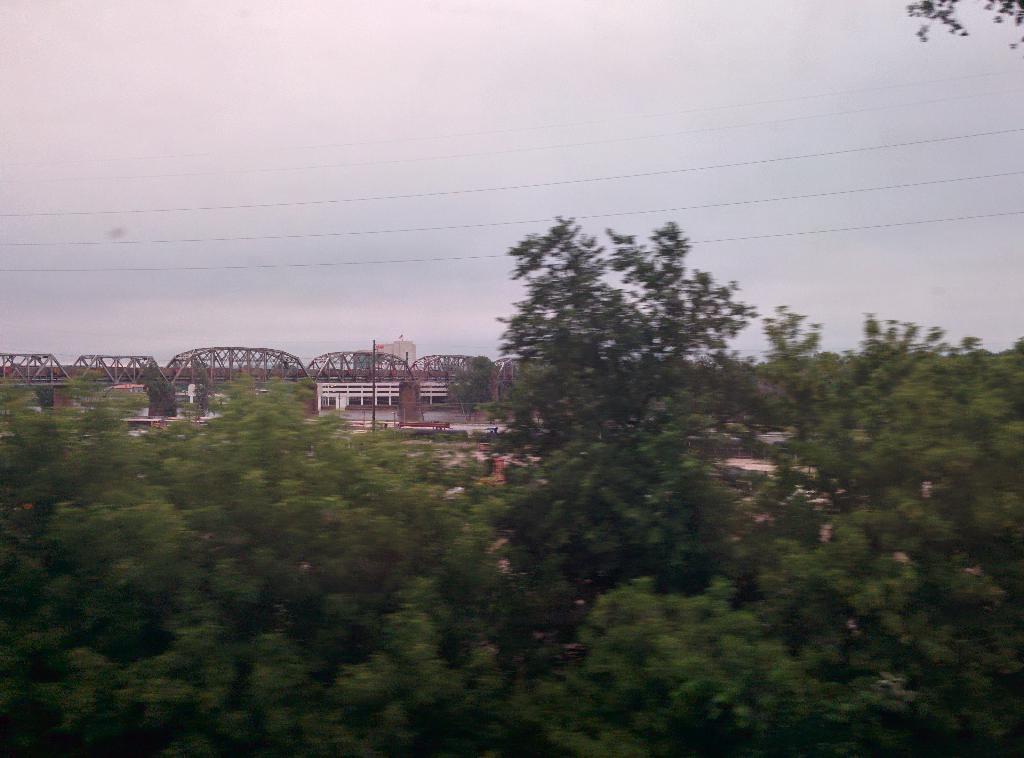In one or two sentences, can you explain what this image depicts? In the picture we can see the trees, bridge, wires and the sky in the background. 